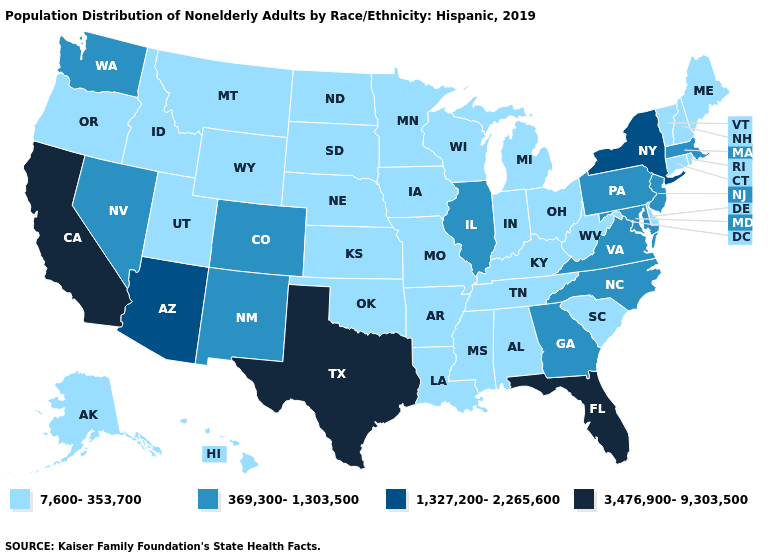Does the first symbol in the legend represent the smallest category?
Give a very brief answer. Yes. Does California have the highest value in the USA?
Keep it brief. Yes. What is the value of North Carolina?
Write a very short answer. 369,300-1,303,500. What is the highest value in the Northeast ?
Answer briefly. 1,327,200-2,265,600. What is the value of Kansas?
Keep it brief. 7,600-353,700. Does Maryland have the lowest value in the USA?
Answer briefly. No. Among the states that border Mississippi , which have the lowest value?
Keep it brief. Alabama, Arkansas, Louisiana, Tennessee. Does the first symbol in the legend represent the smallest category?
Write a very short answer. Yes. Is the legend a continuous bar?
Keep it brief. No. Which states have the lowest value in the MidWest?
Give a very brief answer. Indiana, Iowa, Kansas, Michigan, Minnesota, Missouri, Nebraska, North Dakota, Ohio, South Dakota, Wisconsin. Does Massachusetts have the same value as Delaware?
Be succinct. No. Does Arizona have a higher value than Florida?
Be succinct. No. Name the states that have a value in the range 3,476,900-9,303,500?
Quick response, please. California, Florida, Texas. Name the states that have a value in the range 1,327,200-2,265,600?
Quick response, please. Arizona, New York. How many symbols are there in the legend?
Write a very short answer. 4. 